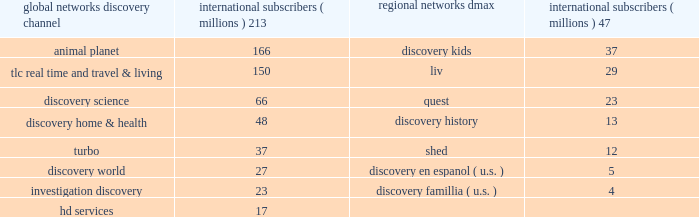Our digital media business consists of our websites and mobile and video-on-demand ( 201cvod 201d ) services .
Our websites include network branded websites such as discovery.com , tlc.com and animalplanet.com , and other websites such as howstuffworks.com , an online source of explanations of how the world actually works ; treehugger.com , a comprehensive source for 201cgreen 201d news , solutions and product information ; and petfinder.com , a leading pet adoption destination .
Together , these websites attracted an average of 24 million cumulative unique monthly visitors , according to comscore , inc .
In 2011 .
International networks our international networks segment principally consists of national and pan-regional television networks .
This segment generates revenues primarily from fees charged to operators who distribute our networks , which primarily include cable and dth satellite service providers , and from advertising sold on our television networks and websites .
Discovery channel , animal planet and tlc lead the international networks 2019 portfolio of television networks , which are distributed in virtually every pay-television market in the world through an infrastructure that includes operational centers in london , singapore and miami .
International networks has one of the largest international distribution platforms of networks with one to twelve networks in more than 200 countries and territories around the world .
At december 31 , 2011 , international networks operated over 150 unique distribution feeds in over 40 languages with channel feeds customized according to language needs and advertising sales opportunities .
Our international networks segment owns and operates the following television networks which reached the following number of subscribers as of december 31 , 2011 : education and other our education and other segment primarily includes the sale of curriculum-based product and service offerings and postproduction audio services .
This segment generates revenues primarily from subscriptions charged to k-12 schools for access to an online suite of curriculum-based vod tools , professional development services , and to a lesser extent student assessment and publication of hardcopy curriculum-based content .
Our education business also participates in corporate partnerships , global brand and content licensing business with leading non-profits , foundations and trade associations .
Other businesses primarily include postproduction audio services that are provided to major motion picture studios , independent producers , broadcast networks , cable channels , advertising agencies , and interactive producers .
Content development our content development strategy is designed to increase viewership , maintain innovation and quality leadership , and provide value for our network distributors and advertising customers .
Substantially all content is sourced from a wide range of third-party producers , which includes some of the world 2019s leading nonfiction production companies with which we have developed long-standing relationships , as well as independent producers .
Our production arrangements fall into three categories : produced , coproduced and licensed .
Substantially all produced content includes programming which we engage third parties to develop and produce while we retain editorial control and own most or all of the rights in exchange for paying all development and production costs .
Coproduced content refers to program rights acquired that we have collaborated with third parties to finance and develop .
Coproduced programs are typically high-cost projects for which neither we nor our coproducers wish to bear the entire cost or productions in which the producer has already taken on an international broadcast partner .
Licensed content is comprised of films or series that have been previously produced by third parties .
Global networks international subscribers ( millions ) regional networks international subscribers ( millions ) .

The largest network is what percent larger than the second largest based on subscribers?\\n? 
Computations: ((213 - 166) / 166)
Answer: 0.28313. 